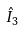<formula> <loc_0><loc_0><loc_500><loc_500>\hat { I } _ { 3 }</formula> 